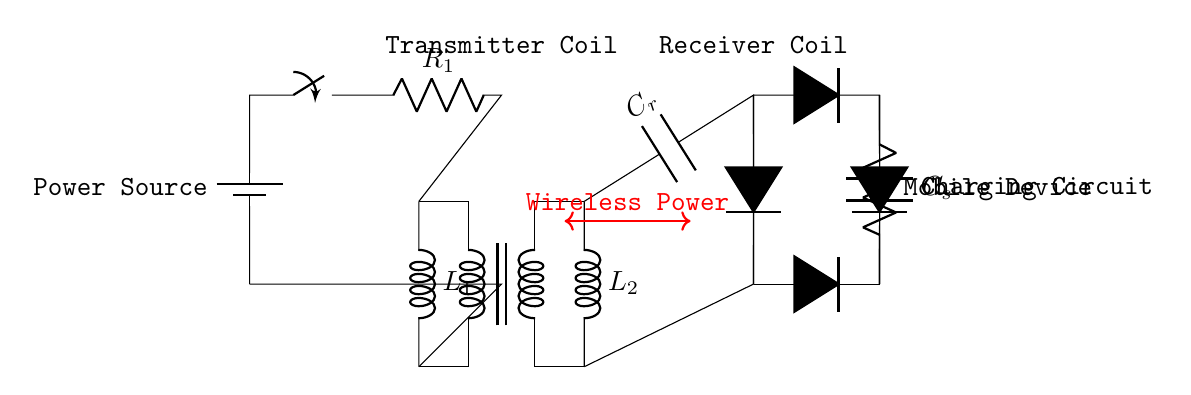What are the two inductors in the circuit? The two inductors present in the circuit are labeled as L1 and L2. These inductors are part of the transformer assembly, which facilitates the transfer of energy wirelessly.
Answer: L1, L2 What component acts as the power source? The power source in the circuit is represented by the battery symbol in the circuit diagram. It is located on the left side of the circuit and supplies the necessary voltage for charging.
Answer: Battery What is the function of the capacitor labeled C_r? The capacitor labeled C_r is a resonant capacitor, which plays a key role in tuning the wireless power transmission. It helps in achieving resonance with the inductors to maximize energy transfer.
Answer: Resonant capacitor How many diodes are used in the bridge rectifier? There are four diodes used in the bridge rectifier as indicated by the D* symbols in the circuit. The arrangement allows for converting the alternating current to direct current for the mobile device charging.
Answer: Four Which component smooths the output voltage? The component that smooths the output voltage in the circuit is labeled C_s, which is a smoothing capacitor. It helps reduce voltage fluctuations after rectification to provide a stable output for the load.
Answer: Smoothing capacitor What type of load is represented at the end of the circuit? The load at the end of the circuit is represented by a resistor labeled as Mobile Device. This symbolizes the device being charged, indicating that it draws current from the charging circuit.
Answer: Mobile Device What does the red arrow represent in the circuit? The red arrow indicates the wireless power transfer between the transmitter coil and the receiver coil. This visual sign shows the mechanism through which energy is transmitted without direct electrical connection.
Answer: Wireless Power 